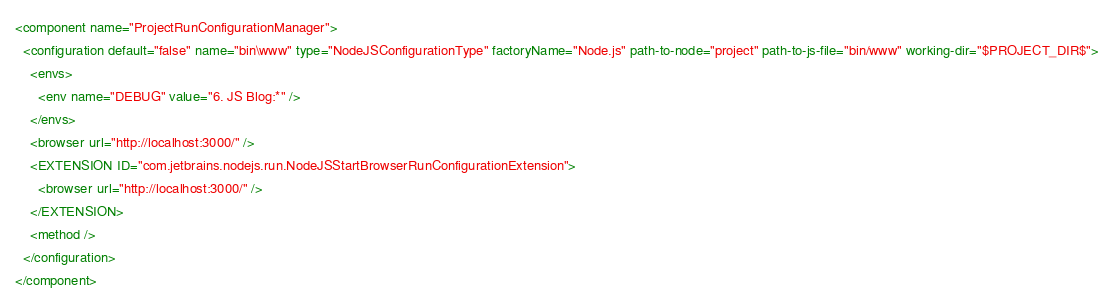Convert code to text. <code><loc_0><loc_0><loc_500><loc_500><_XML_><component name="ProjectRunConfigurationManager">
  <configuration default="false" name="bin\www" type="NodeJSConfigurationType" factoryName="Node.js" path-to-node="project" path-to-js-file="bin/www" working-dir="$PROJECT_DIR$">
    <envs>
      <env name="DEBUG" value="6. JS Blog:*" />
    </envs>
    <browser url="http://localhost:3000/" />
    <EXTENSION ID="com.jetbrains.nodejs.run.NodeJSStartBrowserRunConfigurationExtension">
      <browser url="http://localhost:3000/" />
    </EXTENSION>
    <method />
  </configuration>
</component></code> 